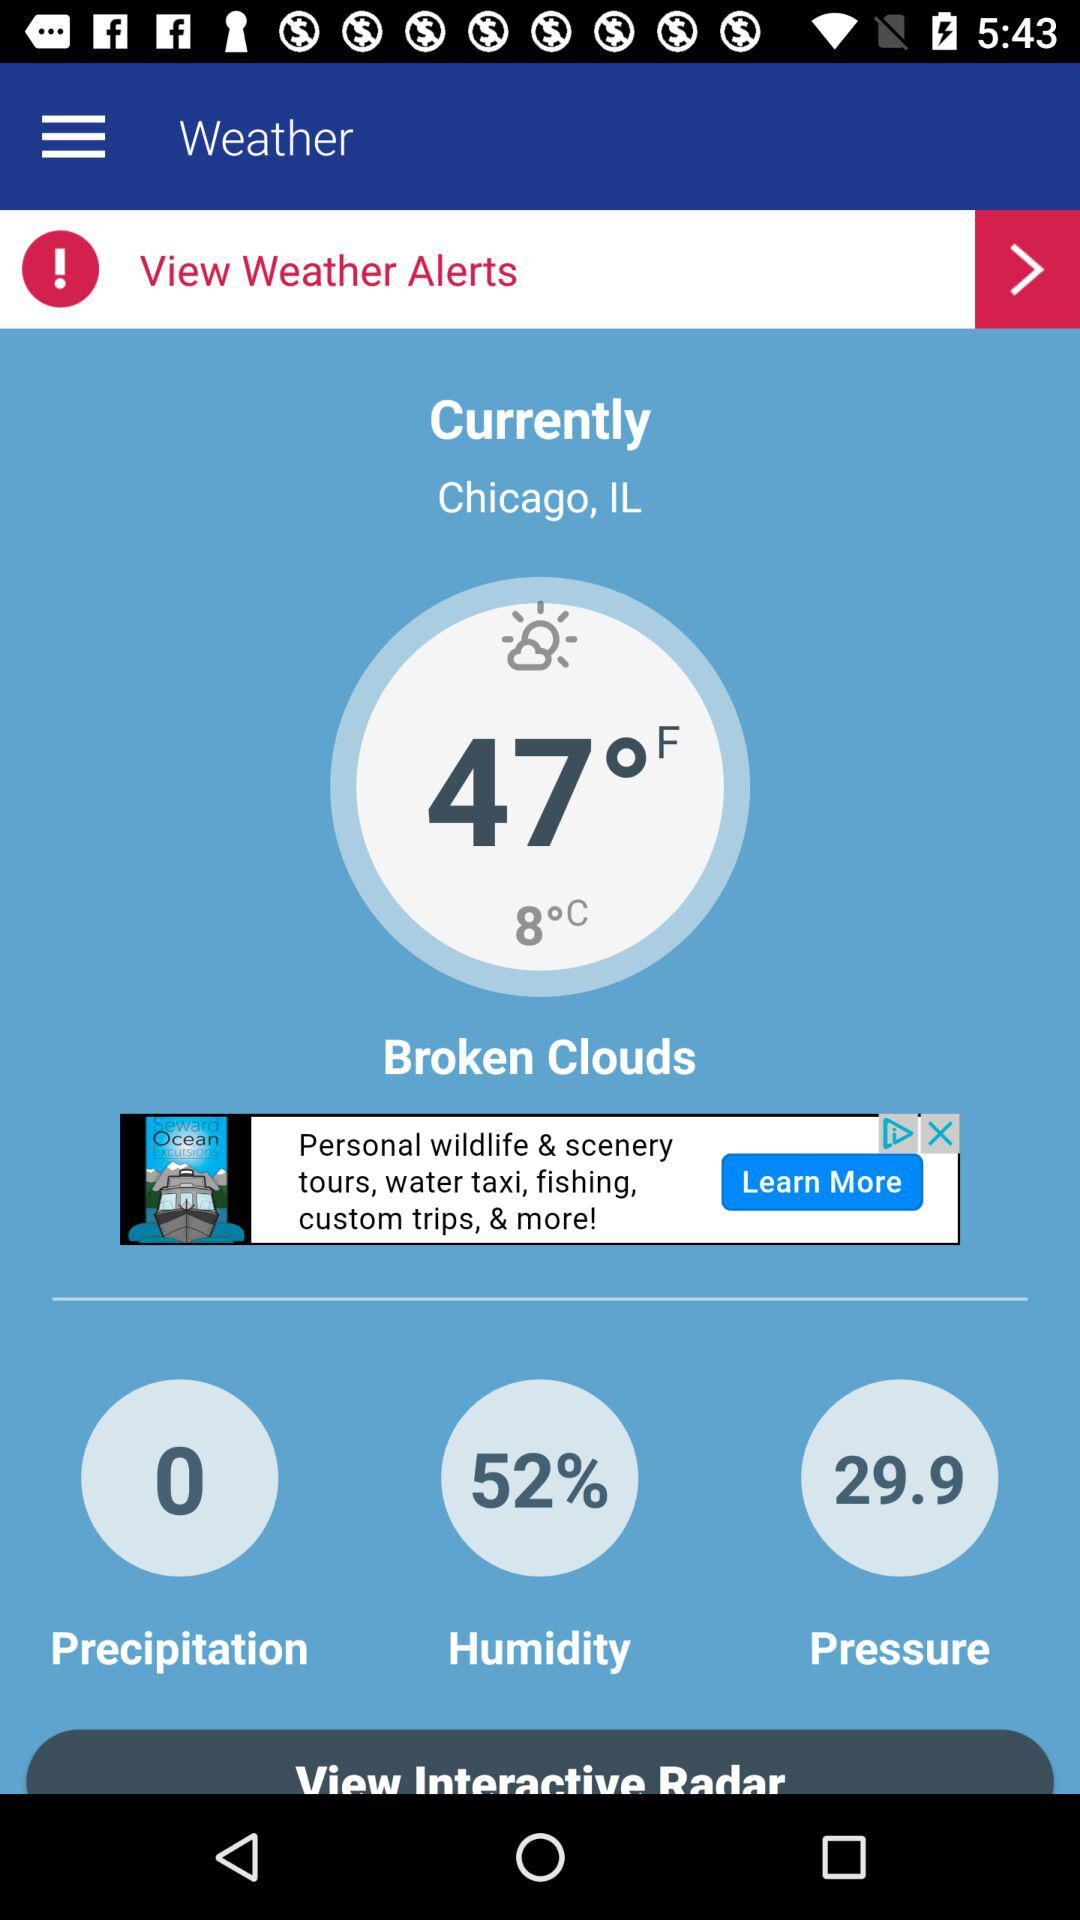What is the humidity percentage?
Answer the question using a single word or phrase. 52% 